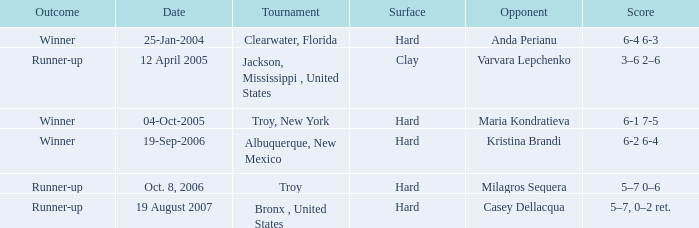What was the outcome of the game played on 19-Sep-2006? Winner. 